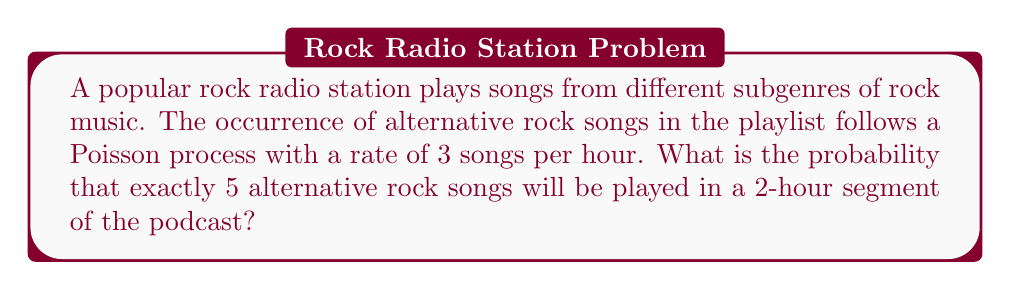Can you solve this math problem? To solve this problem, we'll use the Poisson distribution formula:

$$P(X = k) = \frac{e^{-\lambda} \lambda^k}{k!}$$

Where:
$\lambda$ = average number of events in the given time interval
$k$ = number of events we're calculating the probability for
$e$ = Euler's number (approximately 2.71828)

Step 1: Calculate $\lambda$ for a 2-hour segment
The rate is 3 songs per hour, so for 2 hours:
$\lambda = 3 \times 2 = 6$

Step 2: Plug in the values to the Poisson formula
$k = 5$ (we want exactly 5 songs)
$\lambda = 6$

$$P(X = 5) = \frac{e^{-6} 6^5}{5!}$$

Step 3: Calculate the numerator
$e^{-6} \approx 0.00248$
$6^5 = 7776$
$e^{-6} 6^5 \approx 0.00248 \times 7776 \approx 19.2845$

Step 4: Calculate the denominator
$5! = 5 \times 4 \times 3 \times 2 \times 1 = 120$

Step 5: Divide the numerator by the denominator
$$P(X = 5) = \frac{19.2845}{120} \approx 0.1607$$

Therefore, the probability of exactly 5 alternative rock songs being played in a 2-hour segment is approximately 0.1607 or 16.07%.
Answer: 0.1607 